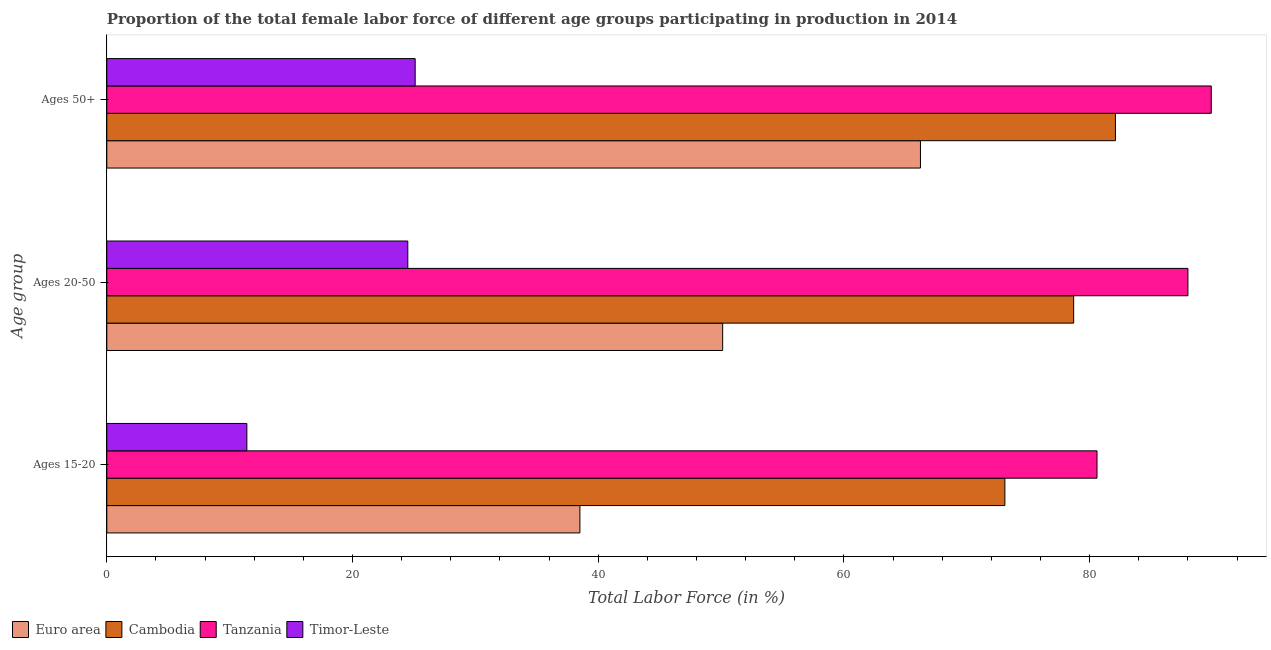How many different coloured bars are there?
Your response must be concise. 4. Are the number of bars on each tick of the Y-axis equal?
Provide a short and direct response. Yes. How many bars are there on the 1st tick from the top?
Offer a very short reply. 4. How many bars are there on the 2nd tick from the bottom?
Provide a short and direct response. 4. What is the label of the 1st group of bars from the top?
Ensure brevity in your answer.  Ages 50+. What is the percentage of female labor force within the age group 15-20 in Timor-Leste?
Give a very brief answer. 11.4. Across all countries, what is the maximum percentage of female labor force above age 50?
Keep it short and to the point. 89.9. Across all countries, what is the minimum percentage of female labor force within the age group 15-20?
Offer a terse response. 11.4. In which country was the percentage of female labor force within the age group 20-50 maximum?
Keep it short and to the point. Tanzania. In which country was the percentage of female labor force within the age group 15-20 minimum?
Provide a short and direct response. Timor-Leste. What is the total percentage of female labor force within the age group 15-20 in the graph?
Your response must be concise. 203.61. What is the difference between the percentage of female labor force above age 50 in Cambodia and that in Euro area?
Your answer should be compact. 15.87. What is the difference between the percentage of female labor force above age 50 in Timor-Leste and the percentage of female labor force within the age group 15-20 in Cambodia?
Your response must be concise. -48. What is the average percentage of female labor force above age 50 per country?
Your response must be concise. 65.83. What is the difference between the percentage of female labor force within the age group 20-50 and percentage of female labor force within the age group 15-20 in Tanzania?
Give a very brief answer. 7.4. What is the ratio of the percentage of female labor force above age 50 in Timor-Leste to that in Euro area?
Your answer should be compact. 0.38. Is the percentage of female labor force within the age group 15-20 in Cambodia less than that in Timor-Leste?
Give a very brief answer. No. Is the difference between the percentage of female labor force within the age group 20-50 in Cambodia and Timor-Leste greater than the difference between the percentage of female labor force within the age group 15-20 in Cambodia and Timor-Leste?
Give a very brief answer. No. What is the difference between the highest and the second highest percentage of female labor force within the age group 15-20?
Provide a succinct answer. 7.5. What is the difference between the highest and the lowest percentage of female labor force within the age group 20-50?
Keep it short and to the point. 63.5. What does the 2nd bar from the top in Ages 20-50 represents?
Make the answer very short. Tanzania. What does the 4th bar from the bottom in Ages 15-20 represents?
Offer a very short reply. Timor-Leste. Does the graph contain any zero values?
Keep it short and to the point. No. Where does the legend appear in the graph?
Ensure brevity in your answer.  Bottom left. What is the title of the graph?
Make the answer very short. Proportion of the total female labor force of different age groups participating in production in 2014. Does "Lithuania" appear as one of the legend labels in the graph?
Offer a very short reply. No. What is the label or title of the Y-axis?
Provide a short and direct response. Age group. What is the Total Labor Force (in %) of Euro area in Ages 15-20?
Your response must be concise. 38.51. What is the Total Labor Force (in %) of Cambodia in Ages 15-20?
Ensure brevity in your answer.  73.1. What is the Total Labor Force (in %) in Tanzania in Ages 15-20?
Offer a terse response. 80.6. What is the Total Labor Force (in %) of Timor-Leste in Ages 15-20?
Provide a short and direct response. 11.4. What is the Total Labor Force (in %) in Euro area in Ages 20-50?
Keep it short and to the point. 50.13. What is the Total Labor Force (in %) of Cambodia in Ages 20-50?
Provide a succinct answer. 78.7. What is the Total Labor Force (in %) in Tanzania in Ages 20-50?
Provide a succinct answer. 88. What is the Total Labor Force (in %) of Euro area in Ages 50+?
Your answer should be very brief. 66.23. What is the Total Labor Force (in %) of Cambodia in Ages 50+?
Offer a terse response. 82.1. What is the Total Labor Force (in %) in Tanzania in Ages 50+?
Offer a very short reply. 89.9. What is the Total Labor Force (in %) in Timor-Leste in Ages 50+?
Provide a succinct answer. 25.1. Across all Age group, what is the maximum Total Labor Force (in %) in Euro area?
Make the answer very short. 66.23. Across all Age group, what is the maximum Total Labor Force (in %) of Cambodia?
Your answer should be compact. 82.1. Across all Age group, what is the maximum Total Labor Force (in %) in Tanzania?
Your answer should be very brief. 89.9. Across all Age group, what is the maximum Total Labor Force (in %) in Timor-Leste?
Your answer should be very brief. 25.1. Across all Age group, what is the minimum Total Labor Force (in %) in Euro area?
Offer a terse response. 38.51. Across all Age group, what is the minimum Total Labor Force (in %) of Cambodia?
Your answer should be compact. 73.1. Across all Age group, what is the minimum Total Labor Force (in %) in Tanzania?
Your answer should be very brief. 80.6. Across all Age group, what is the minimum Total Labor Force (in %) of Timor-Leste?
Give a very brief answer. 11.4. What is the total Total Labor Force (in %) of Euro area in the graph?
Your answer should be compact. 154.87. What is the total Total Labor Force (in %) in Cambodia in the graph?
Keep it short and to the point. 233.9. What is the total Total Labor Force (in %) of Tanzania in the graph?
Your response must be concise. 258.5. What is the difference between the Total Labor Force (in %) in Euro area in Ages 15-20 and that in Ages 20-50?
Offer a terse response. -11.62. What is the difference between the Total Labor Force (in %) of Cambodia in Ages 15-20 and that in Ages 20-50?
Ensure brevity in your answer.  -5.6. What is the difference between the Total Labor Force (in %) of Tanzania in Ages 15-20 and that in Ages 20-50?
Give a very brief answer. -7.4. What is the difference between the Total Labor Force (in %) of Euro area in Ages 15-20 and that in Ages 50+?
Give a very brief answer. -27.72. What is the difference between the Total Labor Force (in %) in Cambodia in Ages 15-20 and that in Ages 50+?
Your answer should be compact. -9. What is the difference between the Total Labor Force (in %) in Timor-Leste in Ages 15-20 and that in Ages 50+?
Offer a terse response. -13.7. What is the difference between the Total Labor Force (in %) of Euro area in Ages 20-50 and that in Ages 50+?
Ensure brevity in your answer.  -16.1. What is the difference between the Total Labor Force (in %) in Cambodia in Ages 20-50 and that in Ages 50+?
Keep it short and to the point. -3.4. What is the difference between the Total Labor Force (in %) of Timor-Leste in Ages 20-50 and that in Ages 50+?
Provide a short and direct response. -0.6. What is the difference between the Total Labor Force (in %) in Euro area in Ages 15-20 and the Total Labor Force (in %) in Cambodia in Ages 20-50?
Your answer should be compact. -40.19. What is the difference between the Total Labor Force (in %) of Euro area in Ages 15-20 and the Total Labor Force (in %) of Tanzania in Ages 20-50?
Offer a very short reply. -49.49. What is the difference between the Total Labor Force (in %) in Euro area in Ages 15-20 and the Total Labor Force (in %) in Timor-Leste in Ages 20-50?
Your answer should be very brief. 14.01. What is the difference between the Total Labor Force (in %) in Cambodia in Ages 15-20 and the Total Labor Force (in %) in Tanzania in Ages 20-50?
Ensure brevity in your answer.  -14.9. What is the difference between the Total Labor Force (in %) of Cambodia in Ages 15-20 and the Total Labor Force (in %) of Timor-Leste in Ages 20-50?
Provide a succinct answer. 48.6. What is the difference between the Total Labor Force (in %) in Tanzania in Ages 15-20 and the Total Labor Force (in %) in Timor-Leste in Ages 20-50?
Offer a terse response. 56.1. What is the difference between the Total Labor Force (in %) in Euro area in Ages 15-20 and the Total Labor Force (in %) in Cambodia in Ages 50+?
Give a very brief answer. -43.59. What is the difference between the Total Labor Force (in %) in Euro area in Ages 15-20 and the Total Labor Force (in %) in Tanzania in Ages 50+?
Provide a short and direct response. -51.39. What is the difference between the Total Labor Force (in %) in Euro area in Ages 15-20 and the Total Labor Force (in %) in Timor-Leste in Ages 50+?
Give a very brief answer. 13.41. What is the difference between the Total Labor Force (in %) of Cambodia in Ages 15-20 and the Total Labor Force (in %) of Tanzania in Ages 50+?
Your response must be concise. -16.8. What is the difference between the Total Labor Force (in %) of Cambodia in Ages 15-20 and the Total Labor Force (in %) of Timor-Leste in Ages 50+?
Give a very brief answer. 48. What is the difference between the Total Labor Force (in %) of Tanzania in Ages 15-20 and the Total Labor Force (in %) of Timor-Leste in Ages 50+?
Offer a terse response. 55.5. What is the difference between the Total Labor Force (in %) in Euro area in Ages 20-50 and the Total Labor Force (in %) in Cambodia in Ages 50+?
Ensure brevity in your answer.  -31.97. What is the difference between the Total Labor Force (in %) of Euro area in Ages 20-50 and the Total Labor Force (in %) of Tanzania in Ages 50+?
Make the answer very short. -39.77. What is the difference between the Total Labor Force (in %) in Euro area in Ages 20-50 and the Total Labor Force (in %) in Timor-Leste in Ages 50+?
Make the answer very short. 25.03. What is the difference between the Total Labor Force (in %) in Cambodia in Ages 20-50 and the Total Labor Force (in %) in Tanzania in Ages 50+?
Ensure brevity in your answer.  -11.2. What is the difference between the Total Labor Force (in %) in Cambodia in Ages 20-50 and the Total Labor Force (in %) in Timor-Leste in Ages 50+?
Your response must be concise. 53.6. What is the difference between the Total Labor Force (in %) of Tanzania in Ages 20-50 and the Total Labor Force (in %) of Timor-Leste in Ages 50+?
Give a very brief answer. 62.9. What is the average Total Labor Force (in %) in Euro area per Age group?
Your response must be concise. 51.62. What is the average Total Labor Force (in %) in Cambodia per Age group?
Offer a very short reply. 77.97. What is the average Total Labor Force (in %) of Tanzania per Age group?
Provide a succinct answer. 86.17. What is the average Total Labor Force (in %) in Timor-Leste per Age group?
Ensure brevity in your answer.  20.33. What is the difference between the Total Labor Force (in %) of Euro area and Total Labor Force (in %) of Cambodia in Ages 15-20?
Your answer should be very brief. -34.59. What is the difference between the Total Labor Force (in %) in Euro area and Total Labor Force (in %) in Tanzania in Ages 15-20?
Offer a very short reply. -42.09. What is the difference between the Total Labor Force (in %) of Euro area and Total Labor Force (in %) of Timor-Leste in Ages 15-20?
Offer a very short reply. 27.11. What is the difference between the Total Labor Force (in %) in Cambodia and Total Labor Force (in %) in Tanzania in Ages 15-20?
Provide a short and direct response. -7.5. What is the difference between the Total Labor Force (in %) of Cambodia and Total Labor Force (in %) of Timor-Leste in Ages 15-20?
Your answer should be compact. 61.7. What is the difference between the Total Labor Force (in %) in Tanzania and Total Labor Force (in %) in Timor-Leste in Ages 15-20?
Keep it short and to the point. 69.2. What is the difference between the Total Labor Force (in %) in Euro area and Total Labor Force (in %) in Cambodia in Ages 20-50?
Offer a terse response. -28.57. What is the difference between the Total Labor Force (in %) in Euro area and Total Labor Force (in %) in Tanzania in Ages 20-50?
Offer a terse response. -37.87. What is the difference between the Total Labor Force (in %) in Euro area and Total Labor Force (in %) in Timor-Leste in Ages 20-50?
Your answer should be very brief. 25.63. What is the difference between the Total Labor Force (in %) of Cambodia and Total Labor Force (in %) of Timor-Leste in Ages 20-50?
Your response must be concise. 54.2. What is the difference between the Total Labor Force (in %) of Tanzania and Total Labor Force (in %) of Timor-Leste in Ages 20-50?
Ensure brevity in your answer.  63.5. What is the difference between the Total Labor Force (in %) in Euro area and Total Labor Force (in %) in Cambodia in Ages 50+?
Keep it short and to the point. -15.87. What is the difference between the Total Labor Force (in %) of Euro area and Total Labor Force (in %) of Tanzania in Ages 50+?
Provide a succinct answer. -23.67. What is the difference between the Total Labor Force (in %) in Euro area and Total Labor Force (in %) in Timor-Leste in Ages 50+?
Keep it short and to the point. 41.13. What is the difference between the Total Labor Force (in %) of Cambodia and Total Labor Force (in %) of Tanzania in Ages 50+?
Provide a succinct answer. -7.8. What is the difference between the Total Labor Force (in %) of Tanzania and Total Labor Force (in %) of Timor-Leste in Ages 50+?
Your answer should be compact. 64.8. What is the ratio of the Total Labor Force (in %) of Euro area in Ages 15-20 to that in Ages 20-50?
Provide a succinct answer. 0.77. What is the ratio of the Total Labor Force (in %) of Cambodia in Ages 15-20 to that in Ages 20-50?
Your answer should be very brief. 0.93. What is the ratio of the Total Labor Force (in %) in Tanzania in Ages 15-20 to that in Ages 20-50?
Your answer should be very brief. 0.92. What is the ratio of the Total Labor Force (in %) in Timor-Leste in Ages 15-20 to that in Ages 20-50?
Make the answer very short. 0.47. What is the ratio of the Total Labor Force (in %) of Euro area in Ages 15-20 to that in Ages 50+?
Give a very brief answer. 0.58. What is the ratio of the Total Labor Force (in %) of Cambodia in Ages 15-20 to that in Ages 50+?
Offer a very short reply. 0.89. What is the ratio of the Total Labor Force (in %) of Tanzania in Ages 15-20 to that in Ages 50+?
Your answer should be compact. 0.9. What is the ratio of the Total Labor Force (in %) of Timor-Leste in Ages 15-20 to that in Ages 50+?
Provide a succinct answer. 0.45. What is the ratio of the Total Labor Force (in %) in Euro area in Ages 20-50 to that in Ages 50+?
Provide a succinct answer. 0.76. What is the ratio of the Total Labor Force (in %) of Cambodia in Ages 20-50 to that in Ages 50+?
Ensure brevity in your answer.  0.96. What is the ratio of the Total Labor Force (in %) of Tanzania in Ages 20-50 to that in Ages 50+?
Your response must be concise. 0.98. What is the ratio of the Total Labor Force (in %) in Timor-Leste in Ages 20-50 to that in Ages 50+?
Make the answer very short. 0.98. What is the difference between the highest and the second highest Total Labor Force (in %) in Euro area?
Your answer should be very brief. 16.1. What is the difference between the highest and the second highest Total Labor Force (in %) of Cambodia?
Offer a very short reply. 3.4. What is the difference between the highest and the second highest Total Labor Force (in %) of Tanzania?
Make the answer very short. 1.9. What is the difference between the highest and the second highest Total Labor Force (in %) of Timor-Leste?
Your answer should be compact. 0.6. What is the difference between the highest and the lowest Total Labor Force (in %) in Euro area?
Keep it short and to the point. 27.72. What is the difference between the highest and the lowest Total Labor Force (in %) of Cambodia?
Give a very brief answer. 9. What is the difference between the highest and the lowest Total Labor Force (in %) in Timor-Leste?
Give a very brief answer. 13.7. 